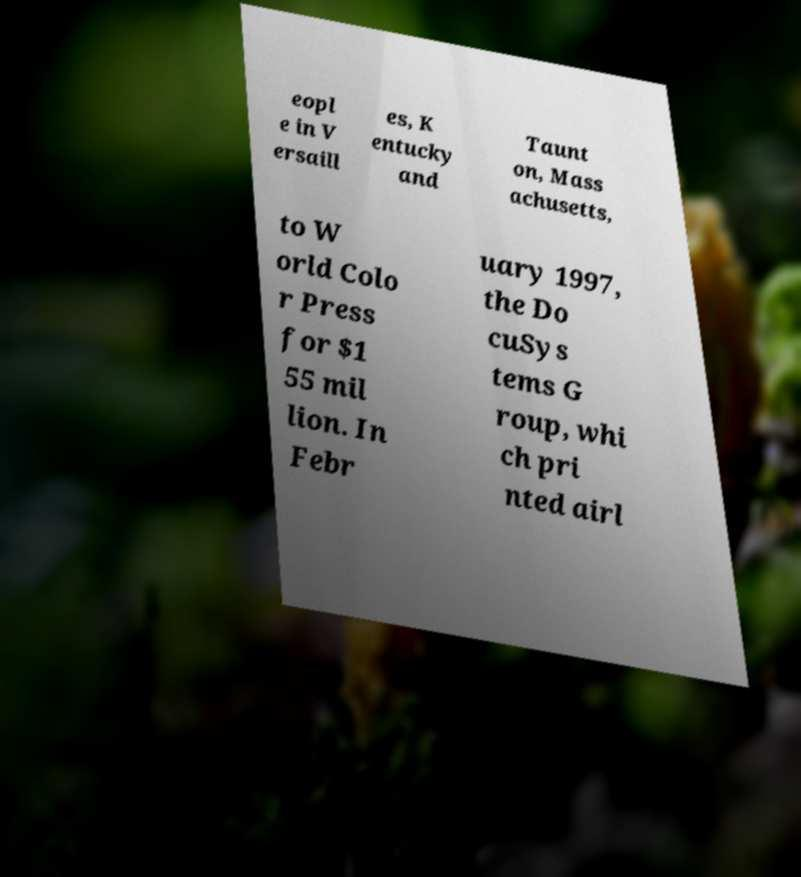What messages or text are displayed in this image? I need them in a readable, typed format. eopl e in V ersaill es, K entucky and Taunt on, Mass achusetts, to W orld Colo r Press for $1 55 mil lion. In Febr uary 1997, the Do cuSys tems G roup, whi ch pri nted airl 